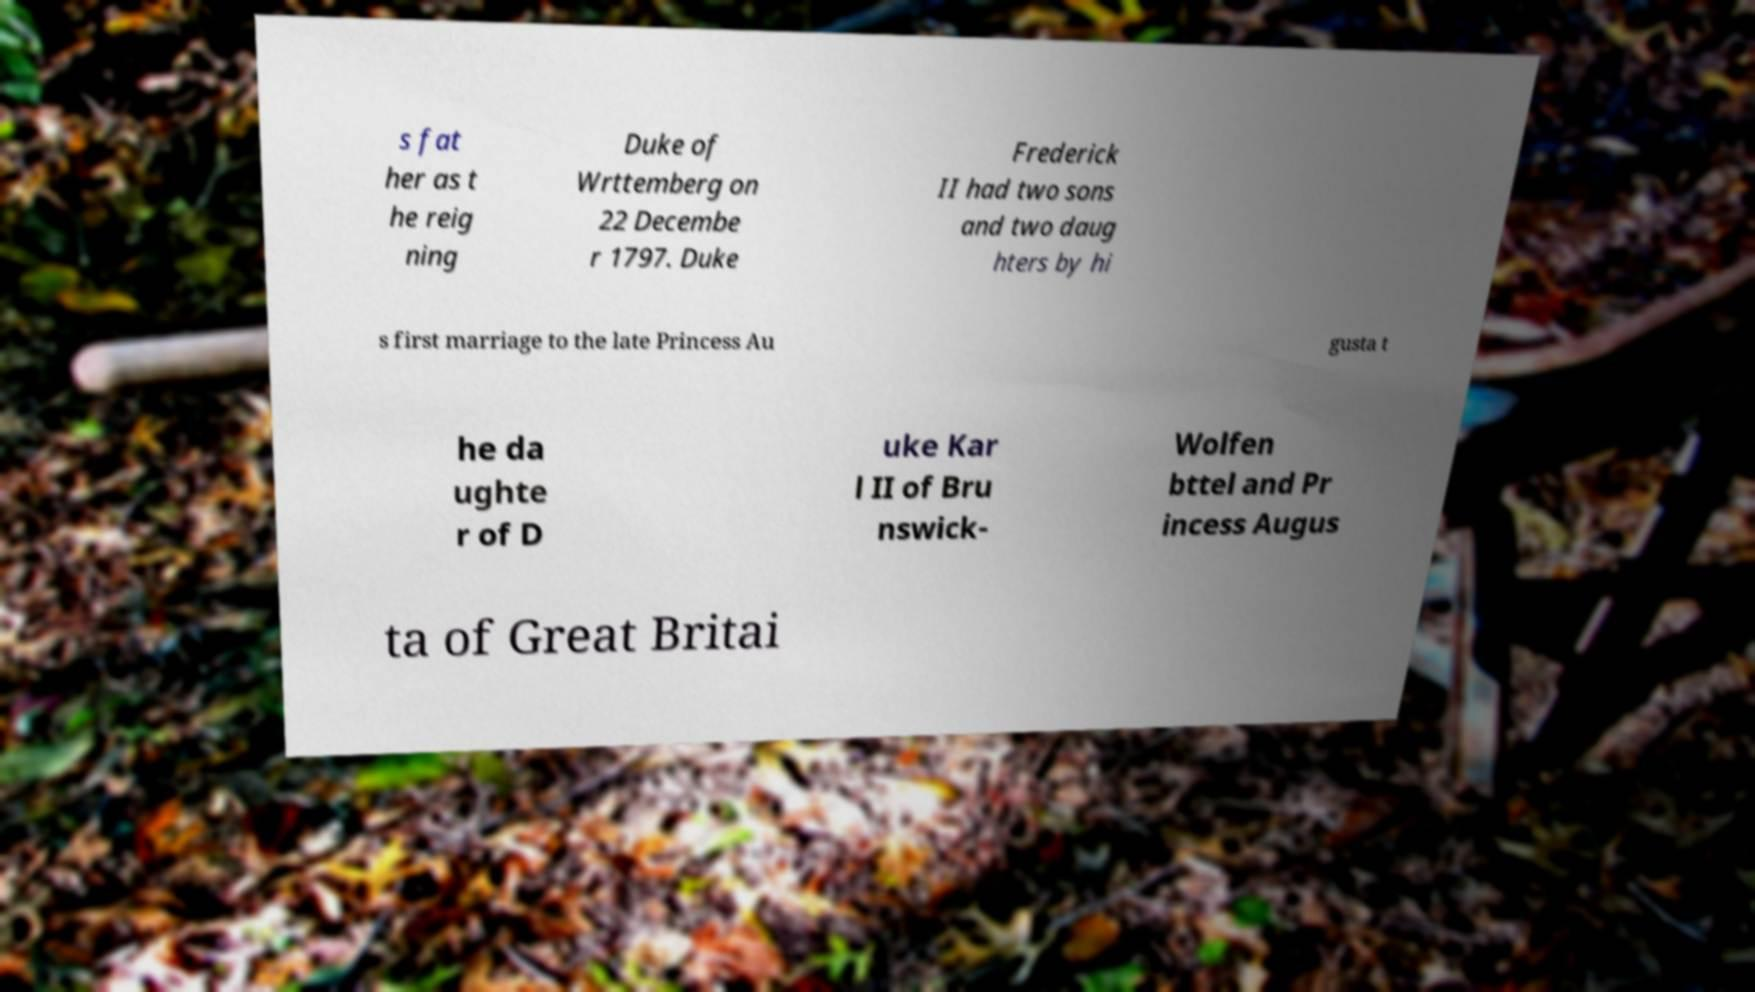Could you extract and type out the text from this image? s fat her as t he reig ning Duke of Wrttemberg on 22 Decembe r 1797. Duke Frederick II had two sons and two daug hters by hi s first marriage to the late Princess Au gusta t he da ughte r of D uke Kar l II of Bru nswick- Wolfen bttel and Pr incess Augus ta of Great Britai 